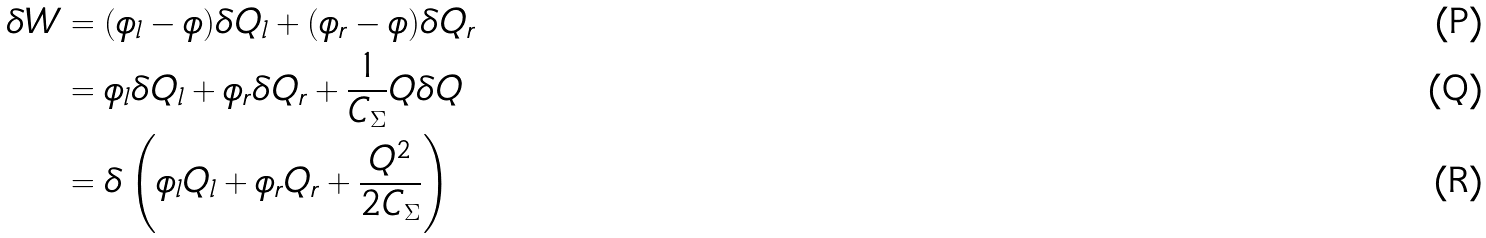Convert formula to latex. <formula><loc_0><loc_0><loc_500><loc_500>\delta W & = ( \phi _ { l } - \phi ) \delta Q _ { l } + ( \phi _ { r } - \phi ) \delta Q _ { r } \\ & = \phi _ { l } \delta Q _ { l } + \phi _ { r } \delta Q _ { r } + \frac { 1 } { C _ { \Sigma } } Q \delta Q \\ & = \delta \left ( \phi _ { l } Q _ { l } + \phi _ { r } Q _ { r } + \frac { Q ^ { 2 } } { 2 C _ { \Sigma } } \right )</formula> 